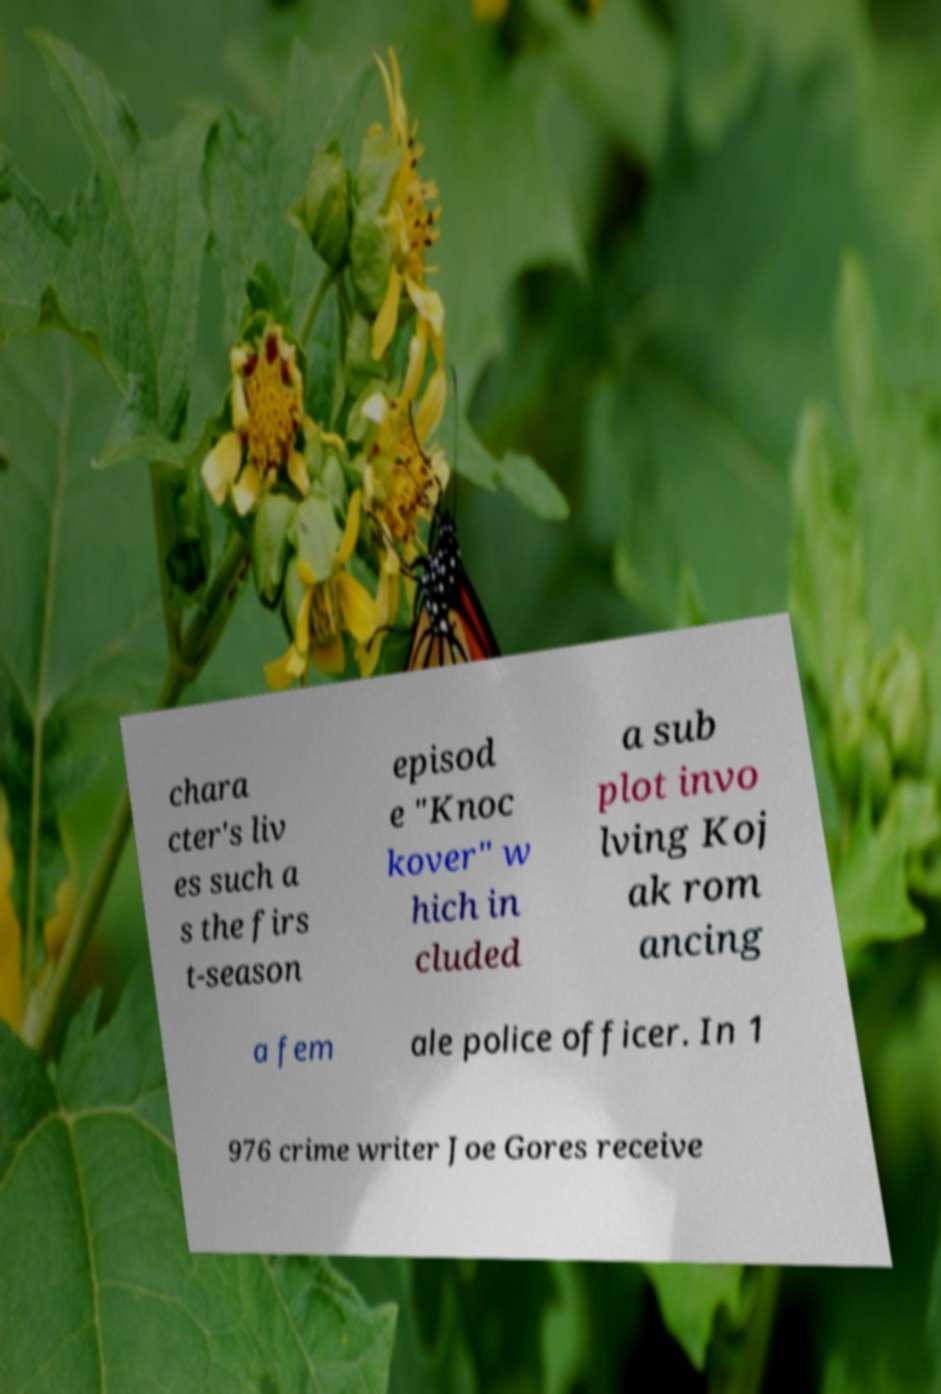Please read and relay the text visible in this image. What does it say? chara cter's liv es such a s the firs t-season episod e "Knoc kover" w hich in cluded a sub plot invo lving Koj ak rom ancing a fem ale police officer. In 1 976 crime writer Joe Gores receive 